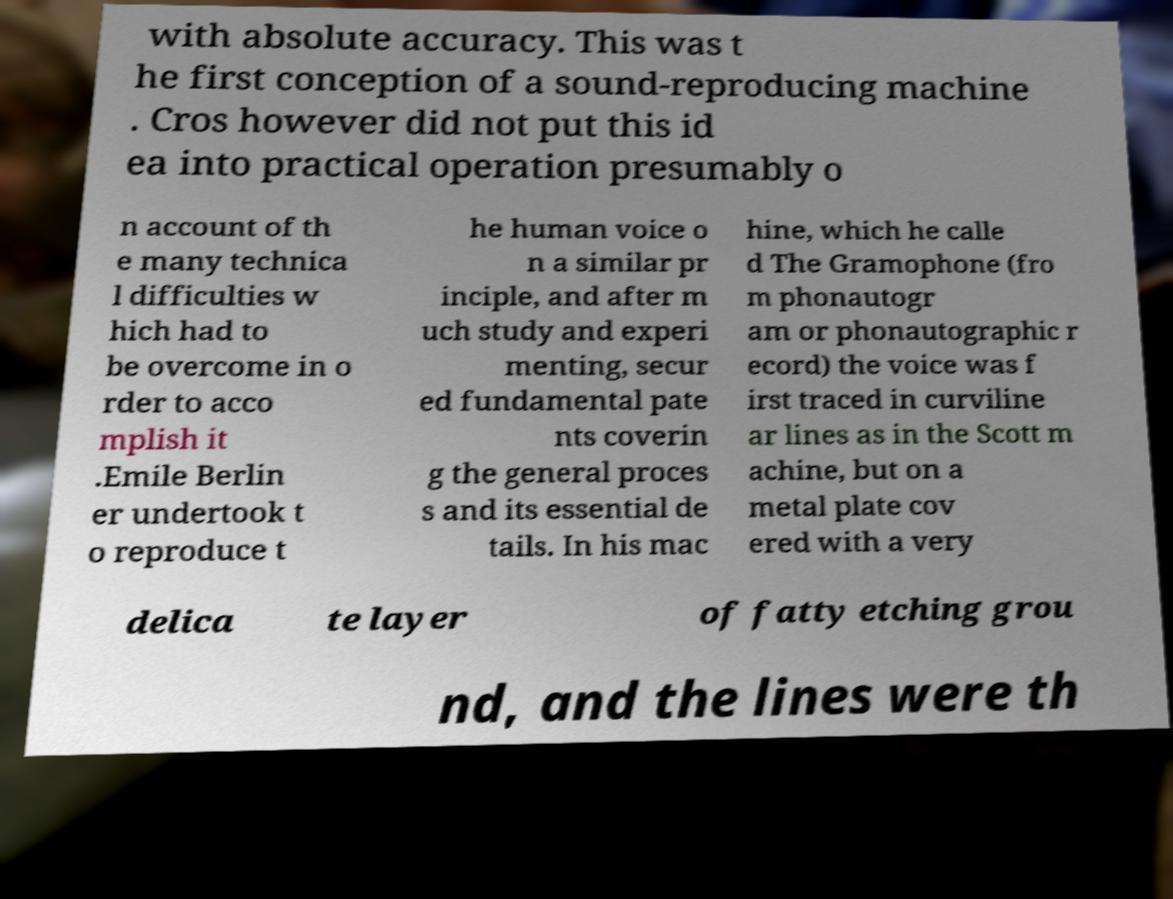Can you accurately transcribe the text from the provided image for me? with absolute accuracy. This was t he first conception of a sound-reproducing machine . Cros however did not put this id ea into practical operation presumably o n account of th e many technica l difficulties w hich had to be overcome in o rder to acco mplish it .Emile Berlin er undertook t o reproduce t he human voice o n a similar pr inciple, and after m uch study and experi menting, secur ed fundamental pate nts coverin g the general proces s and its essential de tails. In his mac hine, which he calle d The Gramophone (fro m phonautogr am or phonautographic r ecord) the voice was f irst traced in curviline ar lines as in the Scott m achine, but on a metal plate cov ered with a very delica te layer of fatty etching grou nd, and the lines were th 